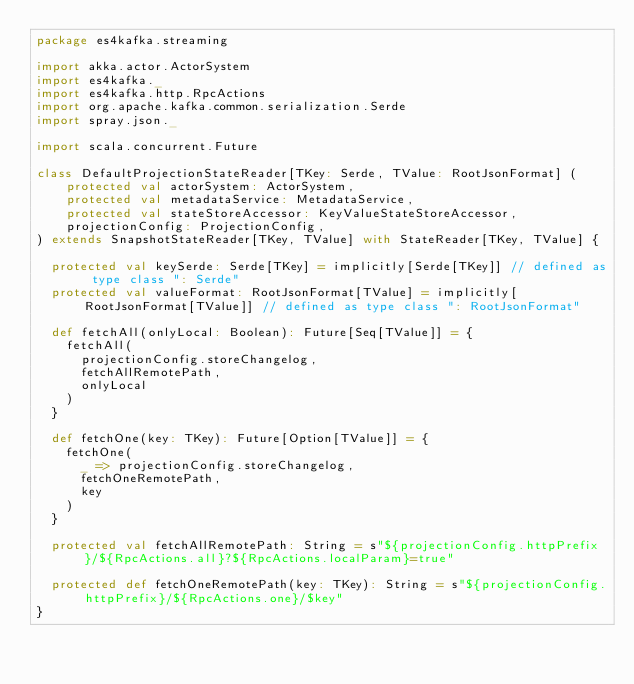<code> <loc_0><loc_0><loc_500><loc_500><_Scala_>package es4kafka.streaming

import akka.actor.ActorSystem
import es4kafka._
import es4kafka.http.RpcActions
import org.apache.kafka.common.serialization.Serde
import spray.json._

import scala.concurrent.Future

class DefaultProjectionStateReader[TKey: Serde, TValue: RootJsonFormat] (
    protected val actorSystem: ActorSystem,
    protected val metadataService: MetadataService,
    protected val stateStoreAccessor: KeyValueStateStoreAccessor,
    projectionConfig: ProjectionConfig,
) extends SnapshotStateReader[TKey, TValue] with StateReader[TKey, TValue] {

  protected val keySerde: Serde[TKey] = implicitly[Serde[TKey]] // defined as type class ": Serde"
  protected val valueFormat: RootJsonFormat[TValue] = implicitly[RootJsonFormat[TValue]] // defined as type class ": RootJsonFormat"

  def fetchAll(onlyLocal: Boolean): Future[Seq[TValue]] = {
    fetchAll(
      projectionConfig.storeChangelog,
      fetchAllRemotePath,
      onlyLocal
    )
  }

  def fetchOne(key: TKey): Future[Option[TValue]] = {
    fetchOne(
      _ => projectionConfig.storeChangelog,
      fetchOneRemotePath,
      key
    )
  }

  protected val fetchAllRemotePath: String = s"${projectionConfig.httpPrefix}/${RpcActions.all}?${RpcActions.localParam}=true"

  protected def fetchOneRemotePath(key: TKey): String = s"${projectionConfig.httpPrefix}/${RpcActions.one}/$key"
}
</code> 